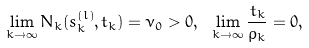<formula> <loc_0><loc_0><loc_500><loc_500>\lim _ { k \rightarrow \infty } N _ { k } ( s _ { k } ^ { ( l ) } , t _ { k } ) = \nu _ { 0 } > 0 , \ \lim _ { k \rightarrow \infty } \frac { t _ { k } } { \rho _ { k } } = 0 ,</formula> 